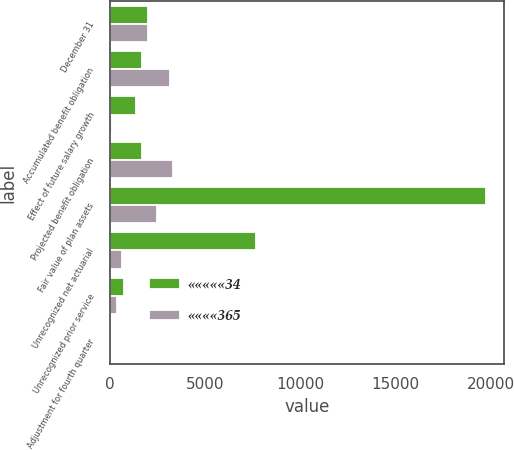Convert chart to OTSL. <chart><loc_0><loc_0><loc_500><loc_500><stacked_bar_chart><ecel><fcel>December 31<fcel>Accumulated benefit obligation<fcel>Effect of future salary growth<fcel>Projected benefit obligation<fcel>Fair value of plan assets<fcel>Unrecognized net actuarial<fcel>Unrecognized prior service<fcel>Adjustment for fourth quarter<nl><fcel>«««««34<fcel>2002<fcel>1697<fcel>1393<fcel>1697<fcel>19709<fcel>7651<fcel>770<fcel>7<nl><fcel>««««365<fcel>2001<fcel>3159<fcel>142<fcel>3301<fcel>2481<fcel>665<fcel>389<fcel>7<nl></chart> 